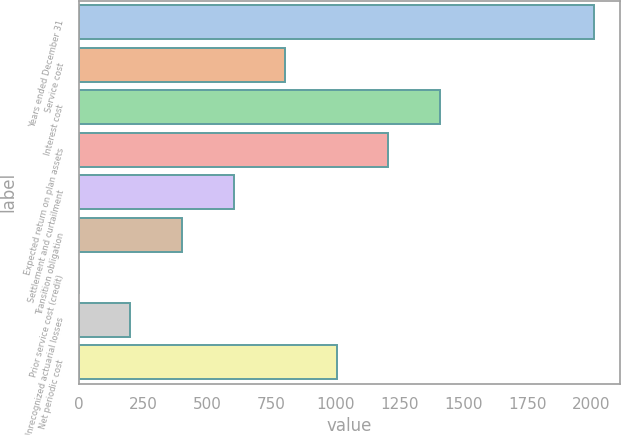<chart> <loc_0><loc_0><loc_500><loc_500><bar_chart><fcel>Years ended December 31<fcel>Service cost<fcel>Interest cost<fcel>Expected return on plan assets<fcel>Settlement and curtailment<fcel>Transition obligation<fcel>Prior service cost (credit)<fcel>Unrecognized actuarial losses<fcel>Net periodic cost<nl><fcel>2011<fcel>804.52<fcel>1407.76<fcel>1206.68<fcel>603.44<fcel>402.36<fcel>0.2<fcel>201.28<fcel>1005.6<nl></chart> 